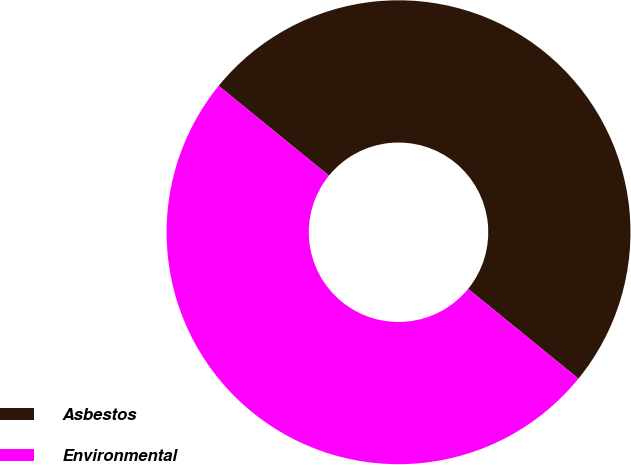Convert chart. <chart><loc_0><loc_0><loc_500><loc_500><pie_chart><fcel>Asbestos<fcel>Environmental<nl><fcel>50.0%<fcel>50.0%<nl></chart> 